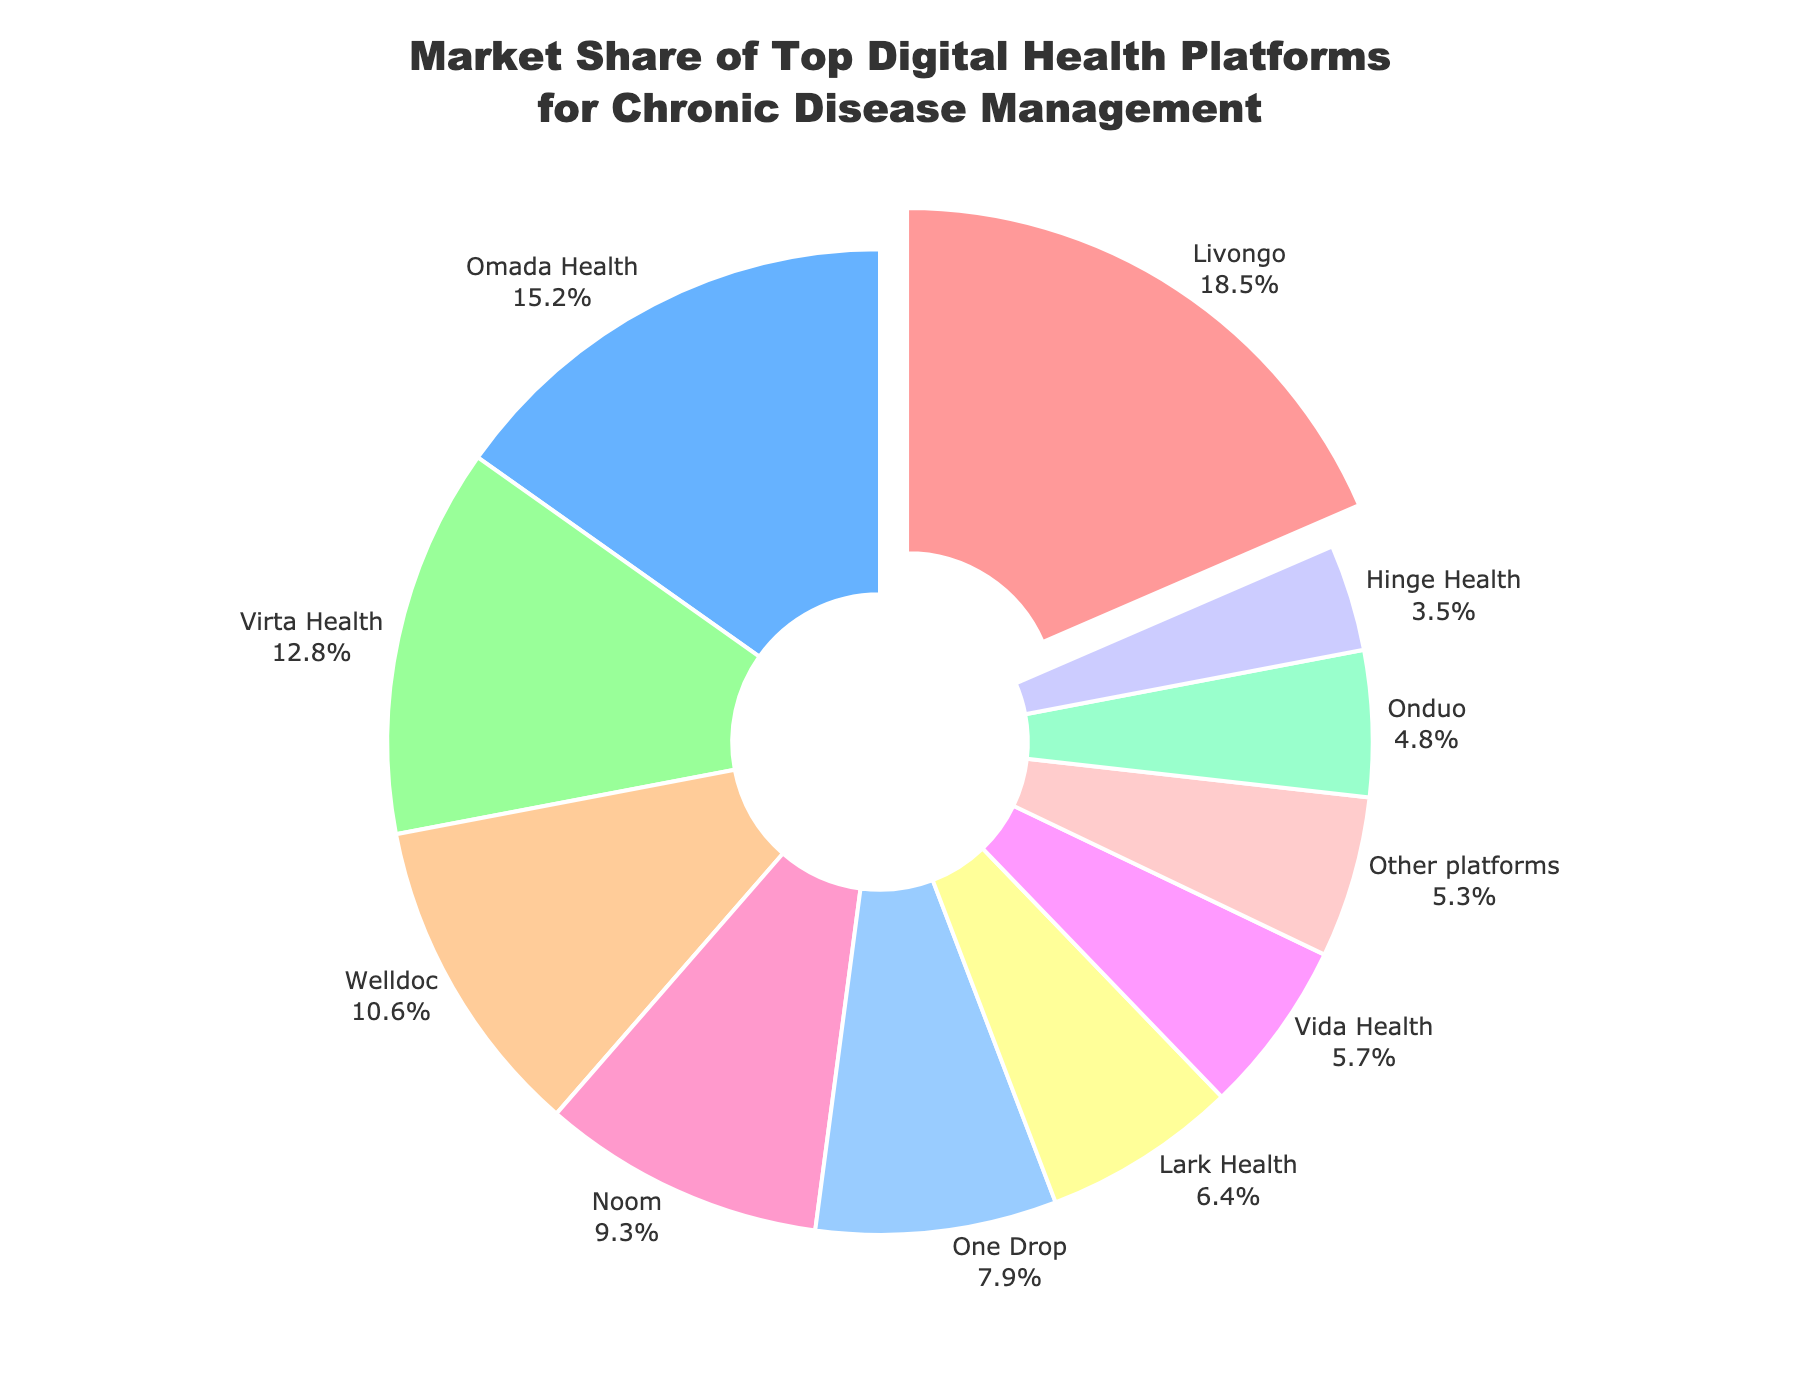What platform has the largest market share? The platform with the largest market share is highlighted by being pulled out slightly from the pie chart. Livongo has 18.5%, which is the largest.
Answer: Livongo What is the market share difference between the platform with the highest share and the platform with the lowest share? The highest market share is Livongo with 18.5% and the lowest is Hinge Health with 3.5%. The difference is calculated as 18.5% - 3.5%.
Answer: 15% Which platforms together account for more than 25% of the market share? Adding the market shares of the platforms: Livongo (18.5%) + Omada Health (15.2%) = 33.7%, which is more than 25%.
Answer: Livongo and Omada Health What is the combined market share of platforms with less than 10% each? The platforms with less than 10% share are: Noom (9.3%), One Drop (7.9%), Lark Health (6.4%), Vida Health (5.7%), Onduo (4.8%), Hinge Health (3.5%), and Other platforms (5.3%). Summing them up: 9.3 + 7.9 + 6.4 + 5.7 + 4.8 + 3.5 + 5.3 = 42.9%.
Answer: 42.9% How many platforms have a market share greater than 10%? Platforms with market shares greater than 10% are Livongo (18.5%), Omada Health (15.2%), Virta Health (12.8%), and Welldoc (10.6%). Counting these yields 4 platforms.
Answer: 4 Which platform has the second smallest market share, and what is its share? By arranging the market shares in ascending order, we find that Onduo has the second smallest share with 4.8%.
Answer: Onduo, 4.8% What percentage of the market share is controlled by the top three platforms? Summing the market shares of the top three platforms: Livongo (18.5%), Omada Health (15.2%), and Virta Health (12.8%). The total is 18.5 + 15.2 + 12.8 = 46.5%.
Answer: 46.5% Is the combined market share of 'Noom' and 'One Drop' more than the combined share of 'Lark Health' and 'Vida Health'? Noom and One Drop have shares of 9.3% and 7.9%, respectively. Combined, this is 9.3 + 7.9 = 17.2%. Lark Health and Vida Health have shares of 6.4% and 5.7%, respectively. Combined, this is 6.4 + 5.7 = 12.1%. Comparing 17.2% and 12.1% confirms that 17.2% is larger.
Answer: Yes Which platforms have a combined share that is equal to or just over 30%? Summing various combinations: Welldoc (10.6%) + Noom (9.3%) + One Drop (7.9%) = 27.8%. Adding Lark Health (6.4%): 27.8 + 6.4 = 34.2% which is over 30%. No other combination using fewer platforms achieves exactly 30%.
Answer: Welldoc, Noom, One Drop What is the market share of the platforms that are neither largest nor smallest in share size? Removing the largest share (Livongo, 18.5%) and the smallest (Hinge Health, 3.5%). Summing up the rest: 15.2 + 12.8 + 10.6 + 9.3 + 7.9 + 6.4 + 5.7 + 4.8 + 5.3 = 78.6%.
Answer: 78.6% 